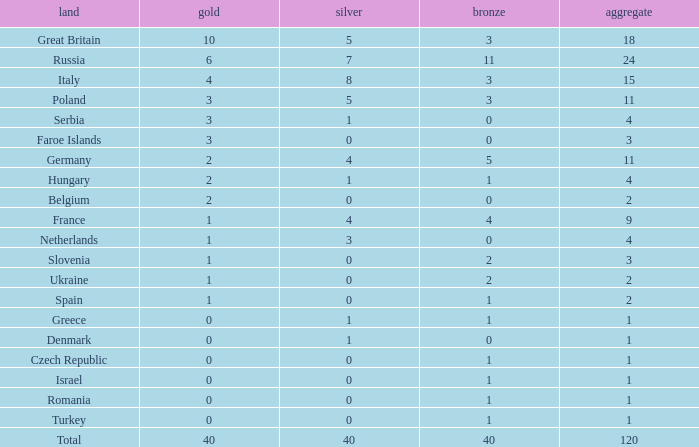What is Turkey's average Gold entry that also has a Bronze entry that is smaller than 2 and the Total is greater than 1? None. 